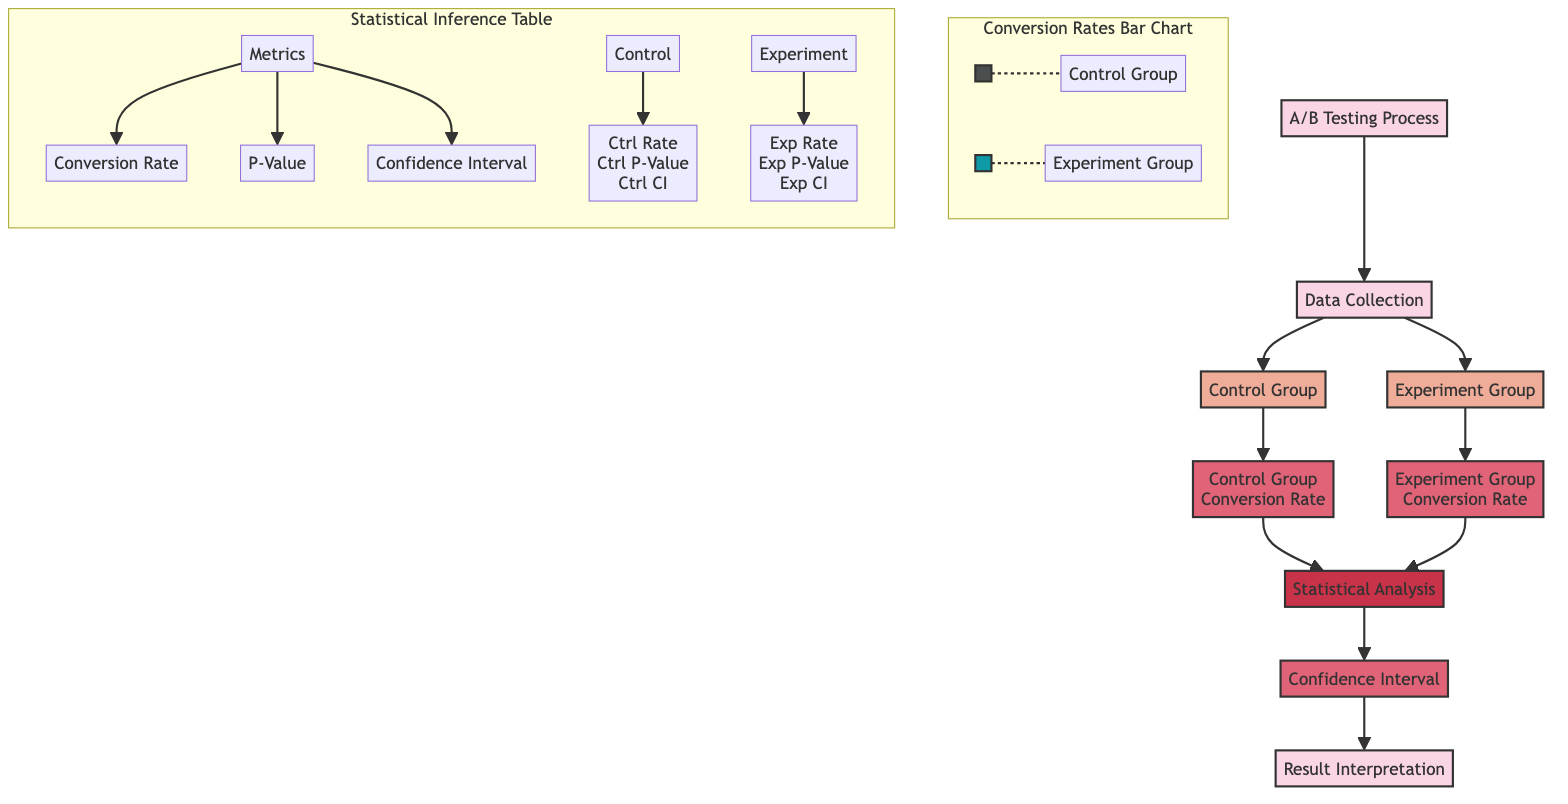What is the first step in the A/B Testing Process? The first step is labeled as "Data Collection" in the diagram, which indicates it is the initial action taken before any analysis.
Answer: Data Collection How many groups are involved in the A/B testing process? The diagram presents two groups: the Control Group and the Experiment Group, making it clear that both are essential for the A/B testing.
Answer: Two What does the term "Control Group Conversion Rate" refer to? It is identified as a metric in the diagram, which focuses on the performance measurement specifically of the control group during the testing phase.
Answer: Control Group Conversion Rate Which component follows the "Statistical Analysis" stage? After conducting the statistical analysis, the next step shown in the diagram is "Confidence Interval," indicating that this component is concerned with measuring the certainty of the results.
Answer: Confidence Interval What two groups are represented in the "Conversion Rates Bar Chart"? The diagram explicitly labels the two groups as "Control Group" and "Experiment Group," indicating that these are the subjects of conversion rate comparison.
Answer: Control Group, Experiment Group What does the Inference Table provide information about? The Inference Table presents key metrics associated with both groups, specifically mentioning three critical elements: Conversion Rate, P-Value, and Confidence Interval for both control and experiment values.
Answer: Conversion Rate, P-Value, Confidence Interval Is the bar color for the Experiment Group different from the Control Group? Yes, the diagram distinguishes the two groups by color-coding: the Control Group is represented in a dark shade while the Experiment Group is in a lighter shade of blue.
Answer: Yes What stage involves interpreting the results of the A/B testing process? The last step outlined in the diagram is "Result Interpretation," indicating that this is where conclusions drawn from the collected data and analysis are articulated.
Answer: Result Interpretation How do the conversion rates for both groups relate to the statistical analysis? The conversion rates for both the Control Group and Experiment Group serve as inputs for the "Statistical Analysis," demonstrating that both rates must be evaluated together to understand the experiment's outcomes.
Answer: They serve as inputs 